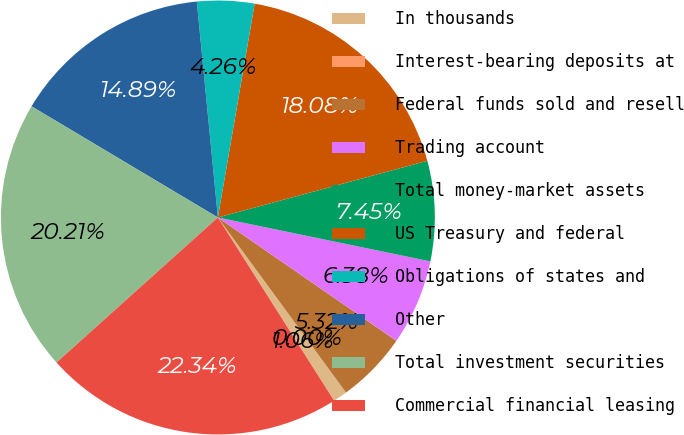Convert chart. <chart><loc_0><loc_0><loc_500><loc_500><pie_chart><fcel>In thousands<fcel>Interest-bearing deposits at<fcel>Federal funds sold and resell<fcel>Trading account<fcel>Total money-market assets<fcel>US Treasury and federal<fcel>Obligations of states and<fcel>Other<fcel>Total investment securities<fcel>Commercial financial leasing<nl><fcel>1.06%<fcel>0.0%<fcel>5.32%<fcel>6.38%<fcel>7.45%<fcel>18.08%<fcel>4.26%<fcel>14.89%<fcel>20.21%<fcel>22.34%<nl></chart> 